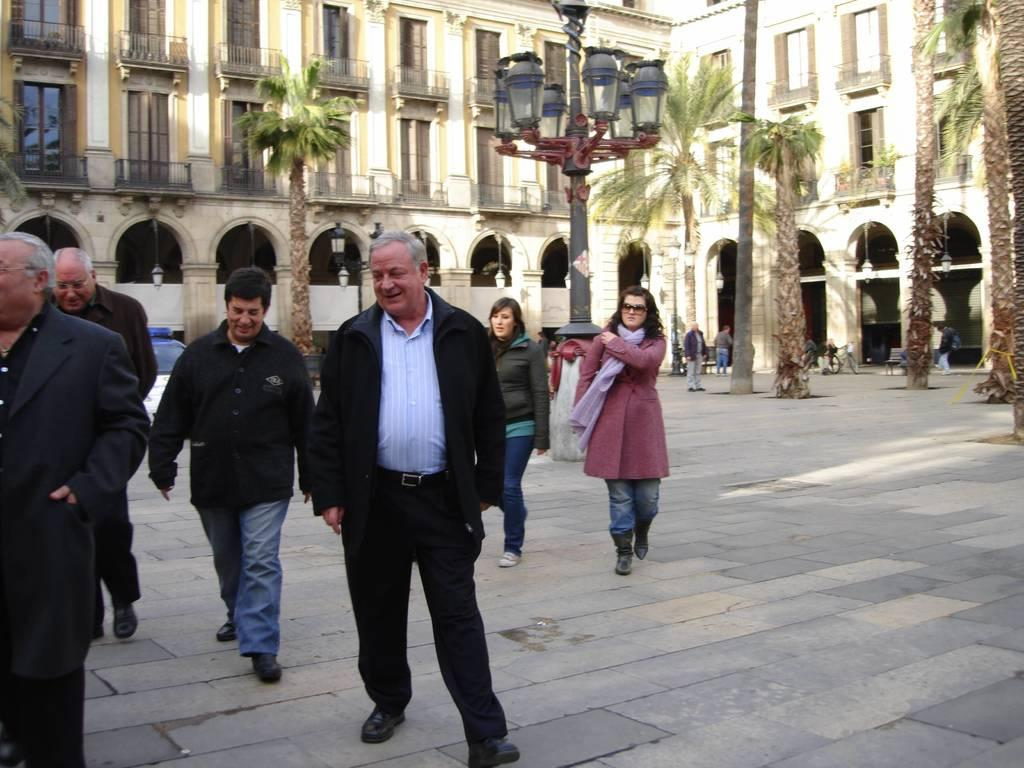What can be seen on the path in the image? There are people on the path in the image. What else is visible in the image besides the people on the path? There are vehicles, street lights, trees, and other objects in the image. What is the background of the image? There is a building in the background of the image. What type of silk fabric is draped over the vehicles in the image? There is no silk fabric present in the image; it features people, vehicles, street lights, trees, and a building in the background. How does the water flow on the path in the image? There is no water present on the path in the image; it features people walking on a dry path. 